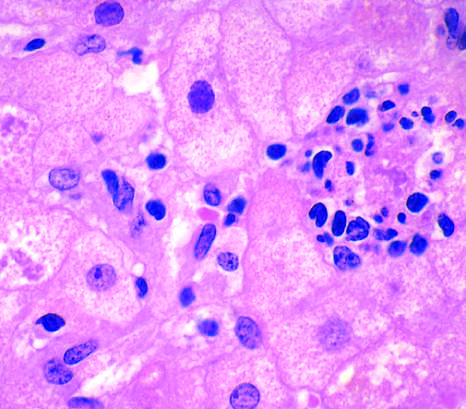what is associated with chronic alcohol use?
Answer the question using a single word or phrase. Hepatoctye injury in fatty liver disease 